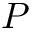Convert formula to latex. <formula><loc_0><loc_0><loc_500><loc_500>P</formula> 